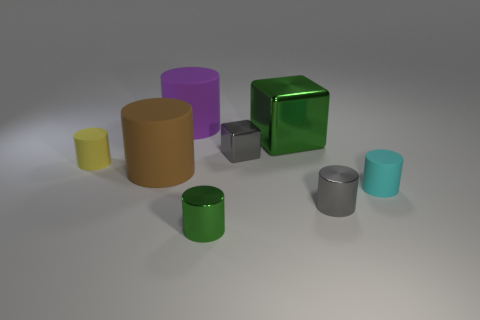There is another thing that is the same color as the big shiny object; what size is it?
Give a very brief answer. Small. How big is the green metal cylinder?
Your answer should be very brief. Small. There is a green metal cylinder; what number of tiny metal objects are right of it?
Your answer should be very brief. 2. There is a green metal object that is behind the green shiny object that is to the left of the large shiny cube; what size is it?
Keep it short and to the point. Large. There is a large metallic object behind the gray metal cube; is its shape the same as the gray metal thing that is in front of the yellow matte cylinder?
Your response must be concise. No. There is a large brown thing that is right of the small rubber thing that is on the left side of the small gray metallic cube; what is its shape?
Your response must be concise. Cylinder. There is a metal object that is left of the large green metal object and behind the tiny cyan cylinder; what is its size?
Keep it short and to the point. Small. Is the shape of the large purple object the same as the small rubber object that is to the right of the purple object?
Keep it short and to the point. Yes. There is a purple rubber object that is the same shape as the tiny green object; what is its size?
Offer a terse response. Large. There is a small metal cube; is its color the same as the rubber cylinder to the right of the large green block?
Make the answer very short. No. 